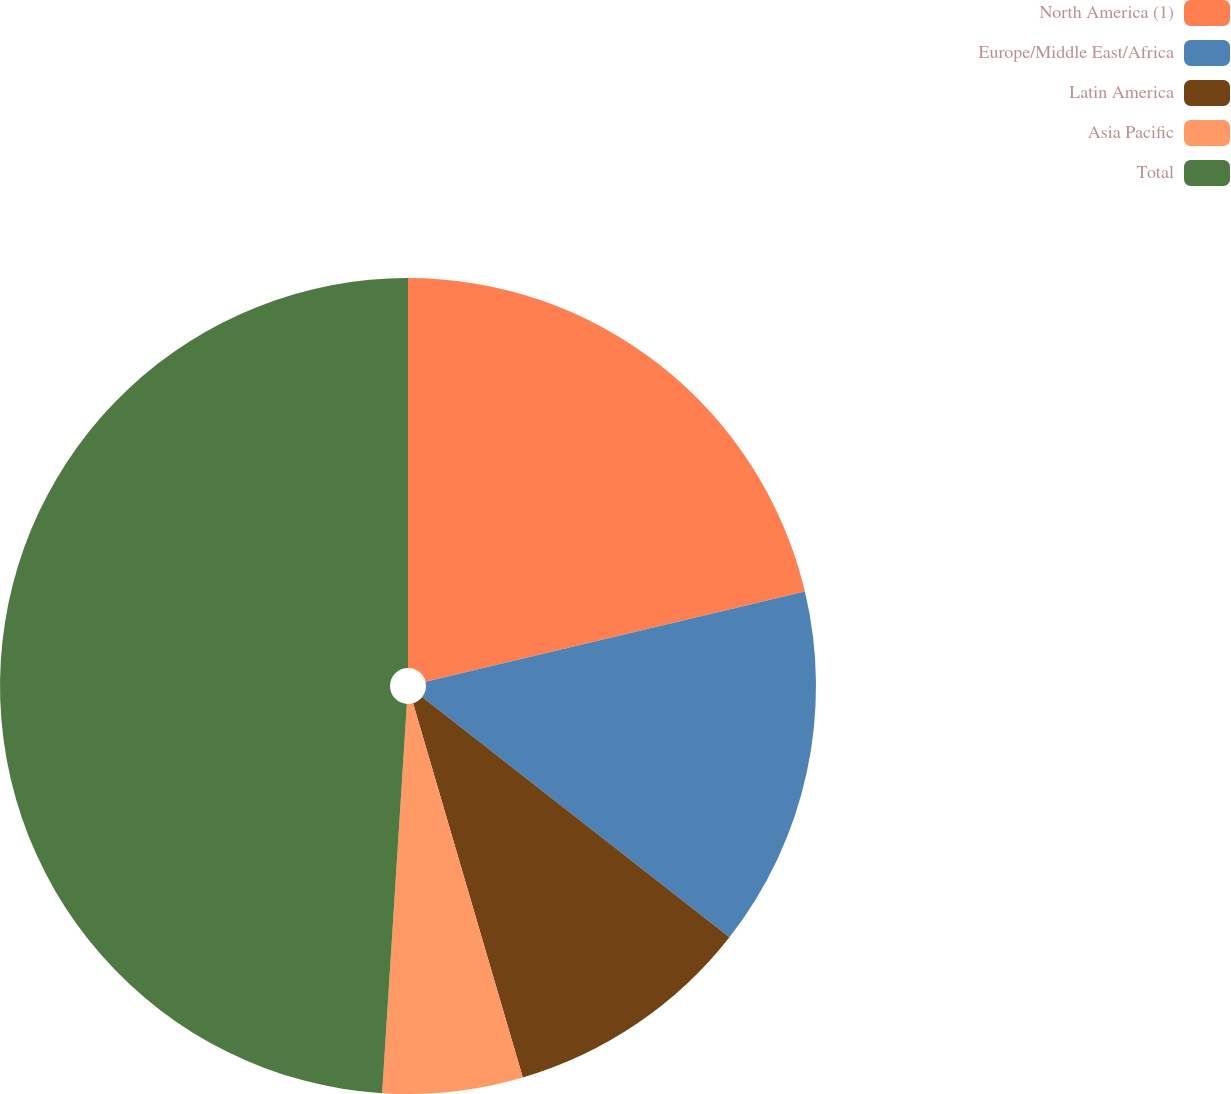Convert chart to OTSL. <chart><loc_0><loc_0><loc_500><loc_500><pie_chart><fcel>North America (1)<fcel>Europe/Middle East/Africa<fcel>Latin America<fcel>Asia Pacific<fcel>Total<nl><fcel>21.28%<fcel>14.28%<fcel>9.9%<fcel>5.55%<fcel>48.99%<nl></chart> 